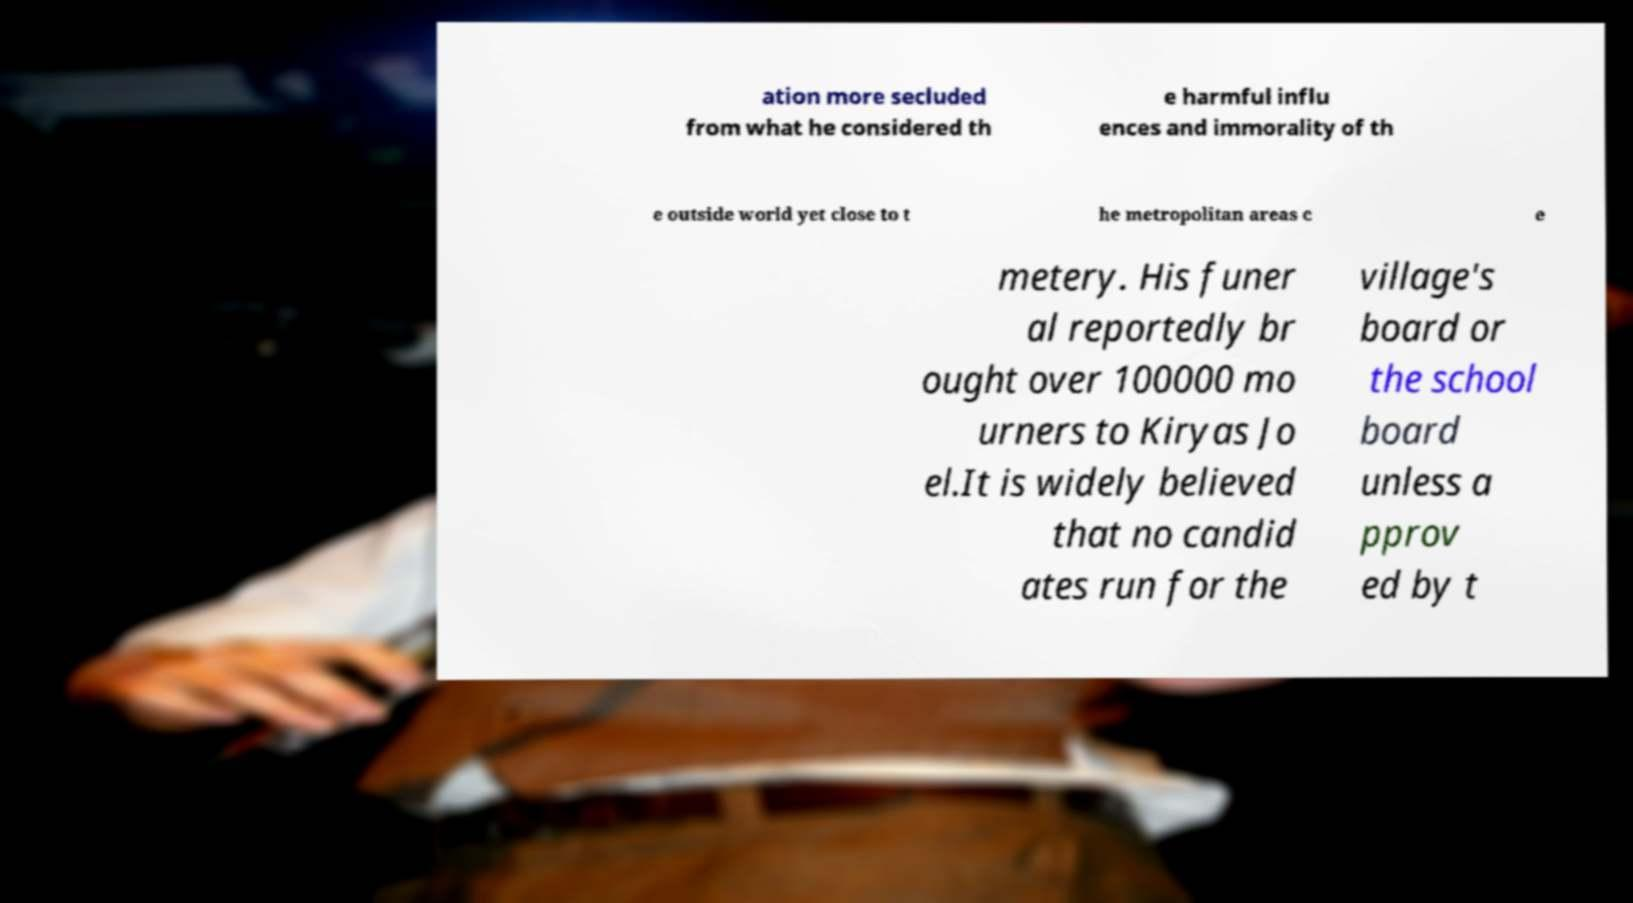Could you assist in decoding the text presented in this image and type it out clearly? ation more secluded from what he considered th e harmful influ ences and immorality of th e outside world yet close to t he metropolitan areas c e metery. His funer al reportedly br ought over 100000 mo urners to Kiryas Jo el.It is widely believed that no candid ates run for the village's board or the school board unless a pprov ed by t 